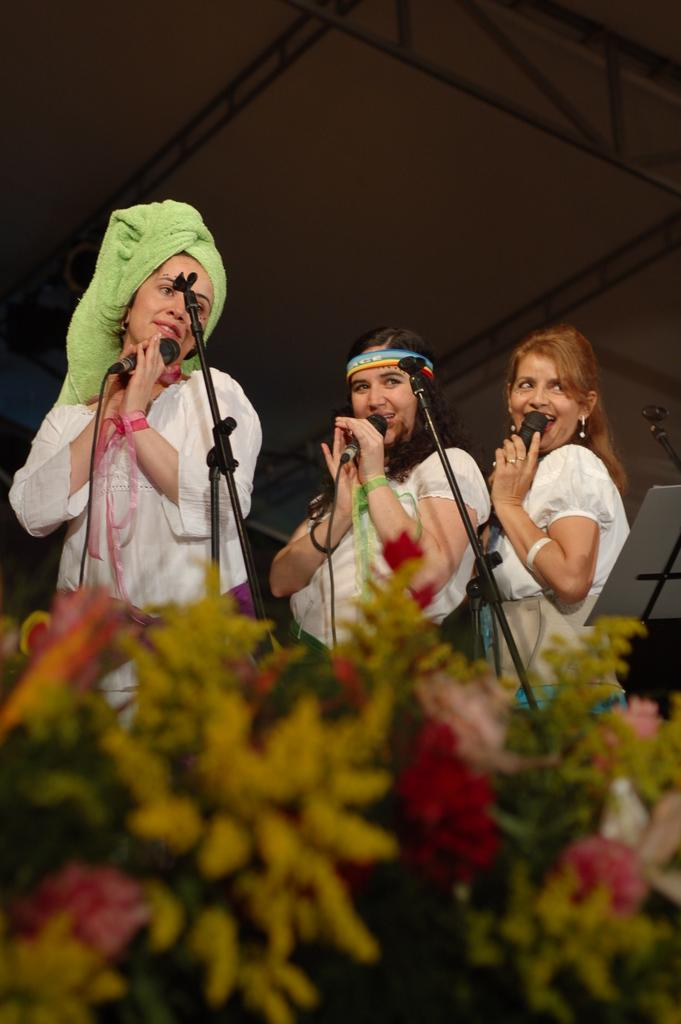Who is present in the image? There are women in the image. What are the women holding in the image? The women are holding microphones. What is in front of the women? There is a stand in front of the women. What decorative elements are present in front of the stand? There are flowers in front of the stand. What can be seen in the background of the image? There are metal rods visible in the background. What type of suit are the boys wearing in the image? There are no boys present in the image, only women. 